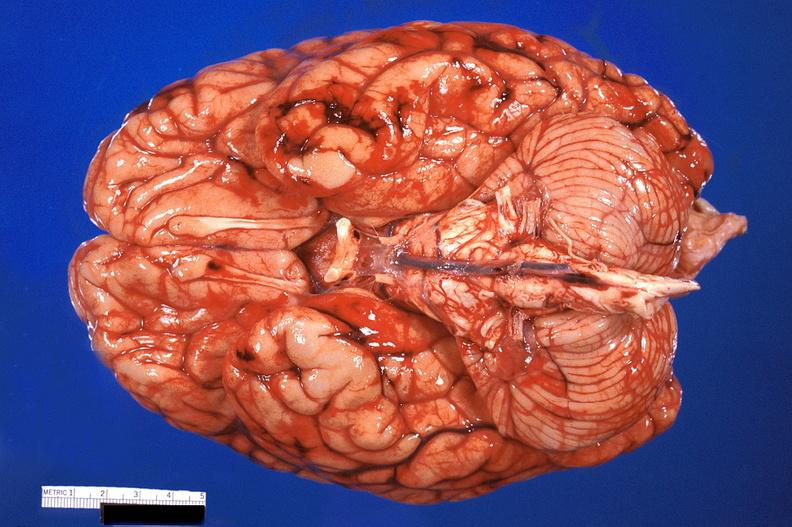s nervous present?
Answer the question using a single word or phrase. Yes 